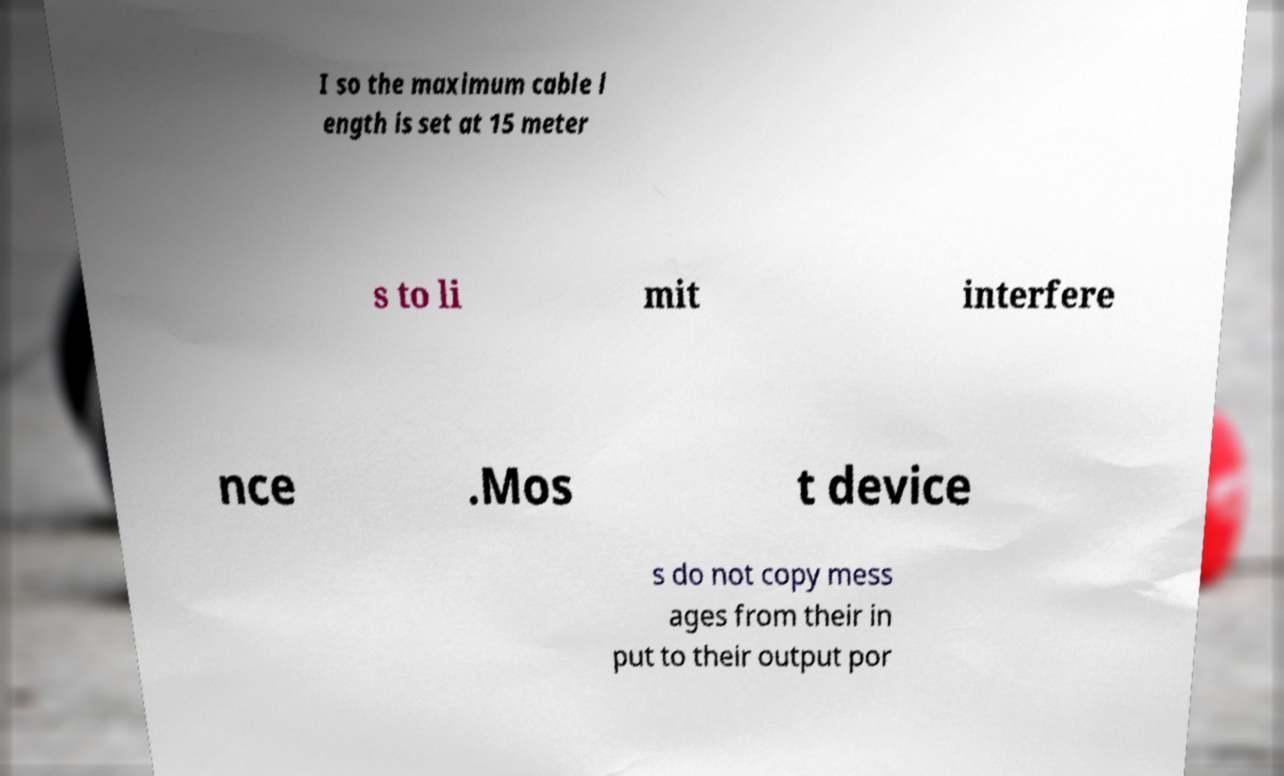Please read and relay the text visible in this image. What does it say? I so the maximum cable l ength is set at 15 meter s to li mit interfere nce .Mos t device s do not copy mess ages from their in put to their output por 